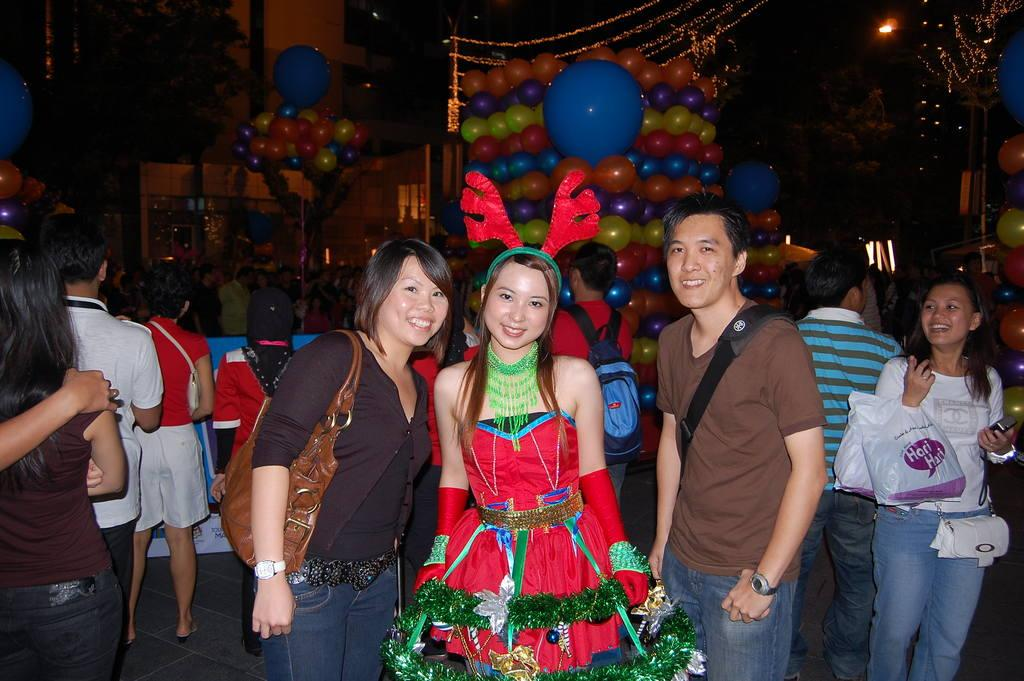What is the main subject of the image? The main subject of the image is a group of people. What are the people in the image doing? The people are standing in the image. Can you describe the expressions of the people in the group? Some of the people in the group are smiling. What can be seen in the background of the image? There are balloons and other objects visible in the background of the image. How many sheep can be seen in the image? There are no sheep present in the image. What type of rake is being used by the people in the image? There is no rake visible in the image; the people are standing and not using any tools. 